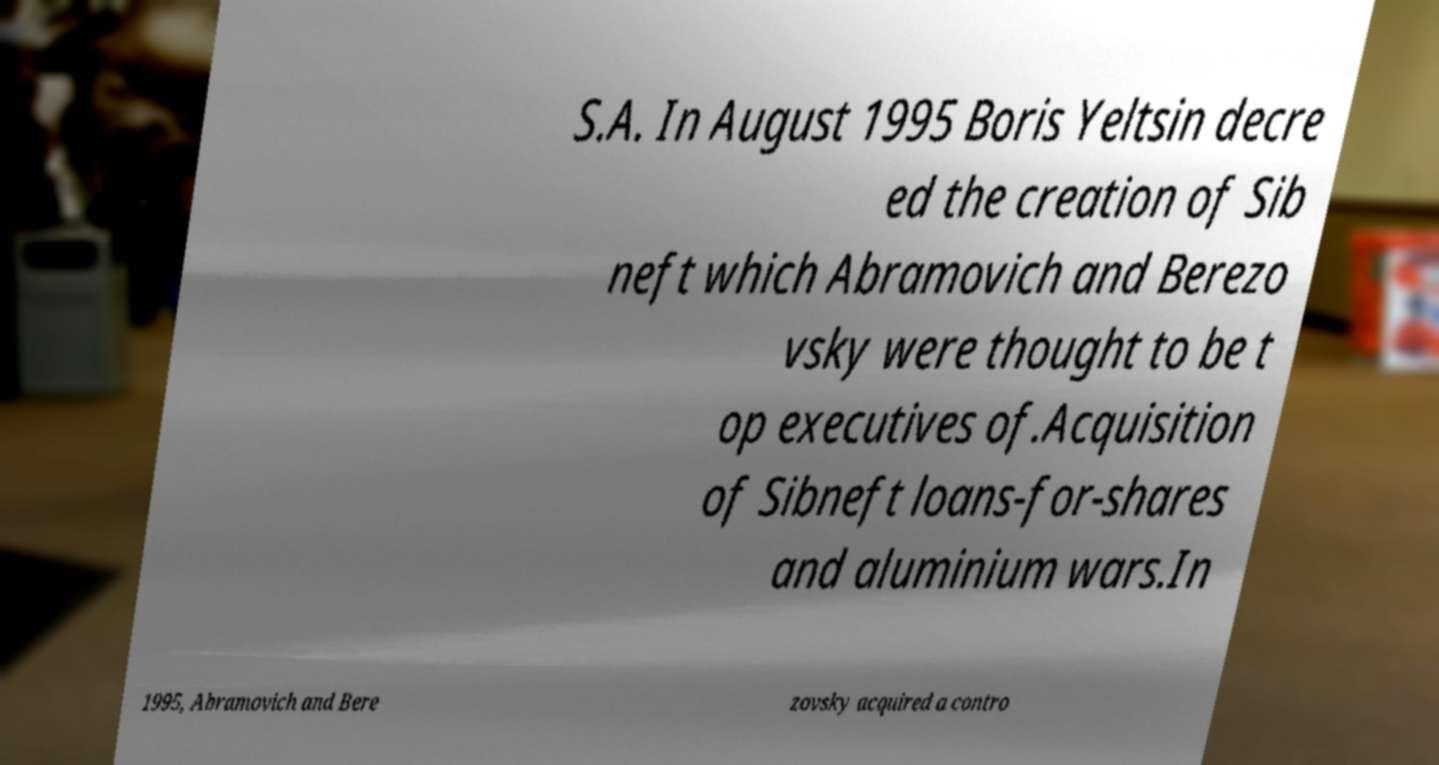Can you read and provide the text displayed in the image?This photo seems to have some interesting text. Can you extract and type it out for me? S.A. In August 1995 Boris Yeltsin decre ed the creation of Sib neft which Abramovich and Berezo vsky were thought to be t op executives of.Acquisition of Sibneft loans-for-shares and aluminium wars.In 1995, Abramovich and Bere zovsky acquired a contro 